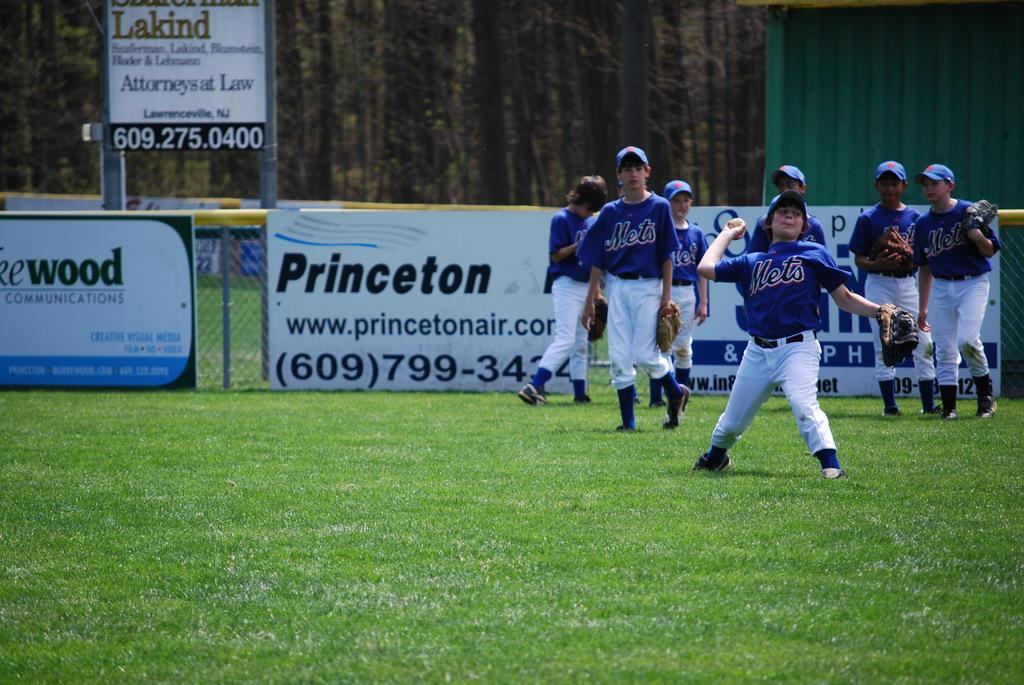<image>
Summarize the visual content of the image. a young boys Mets baseball team in front of a princeton billboard 